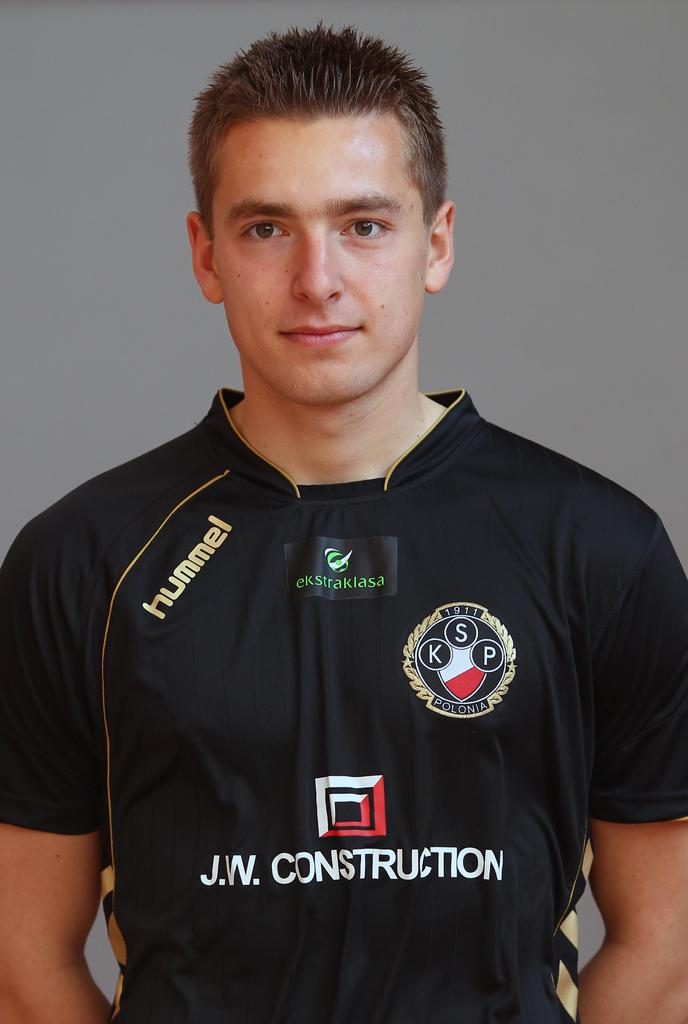<image>
Render a clear and concise summary of the photo. A guy is wearing a jersey with a hummel logo on it. 